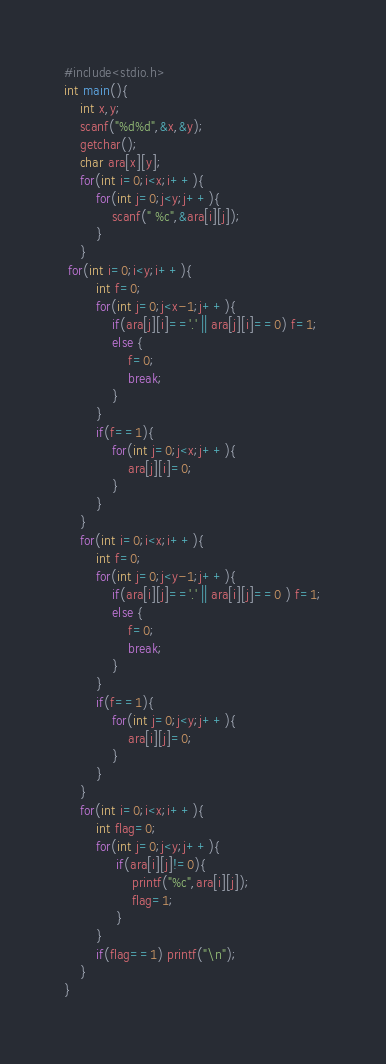Convert code to text. <code><loc_0><loc_0><loc_500><loc_500><_C_>#include<stdio.h>
int main(){
    int x,y;
    scanf("%d%d",&x,&y);
    getchar();
    char ara[x][y];
    for(int i=0;i<x;i++){
        for(int j=0;j<y;j++){
            scanf(" %c",&ara[i][j]);
        }
    }
 for(int i=0;i<y;i++){
        int f=0;
        for(int j=0;j<x-1;j++){
            if(ara[j][i]=='.' || ara[j][i]==0) f=1;
            else {
                f=0;
                break;
            }
        }
        if(f==1){
            for(int j=0;j<x;j++){
                ara[j][i]=0;
            }
        }
    }
    for(int i=0;i<x;i++){
        int f=0;
        for(int j=0;j<y-1;j++){
            if(ara[i][j]=='.' || ara[i][j]==0 ) f=1;
            else {
                f=0;
                break;
            }
        }
        if(f==1){
            for(int j=0;j<y;j++){
                ara[i][j]=0;
            }
        }
    }
    for(int i=0;i<x;i++){
        int flag=0;
        for(int j=0;j<y;j++){
             if(ara[i][j]!=0){
                 printf("%c",ara[i][j]);
                 flag=1;
             }
        }
        if(flag==1) printf("\n");
    }
}</code> 